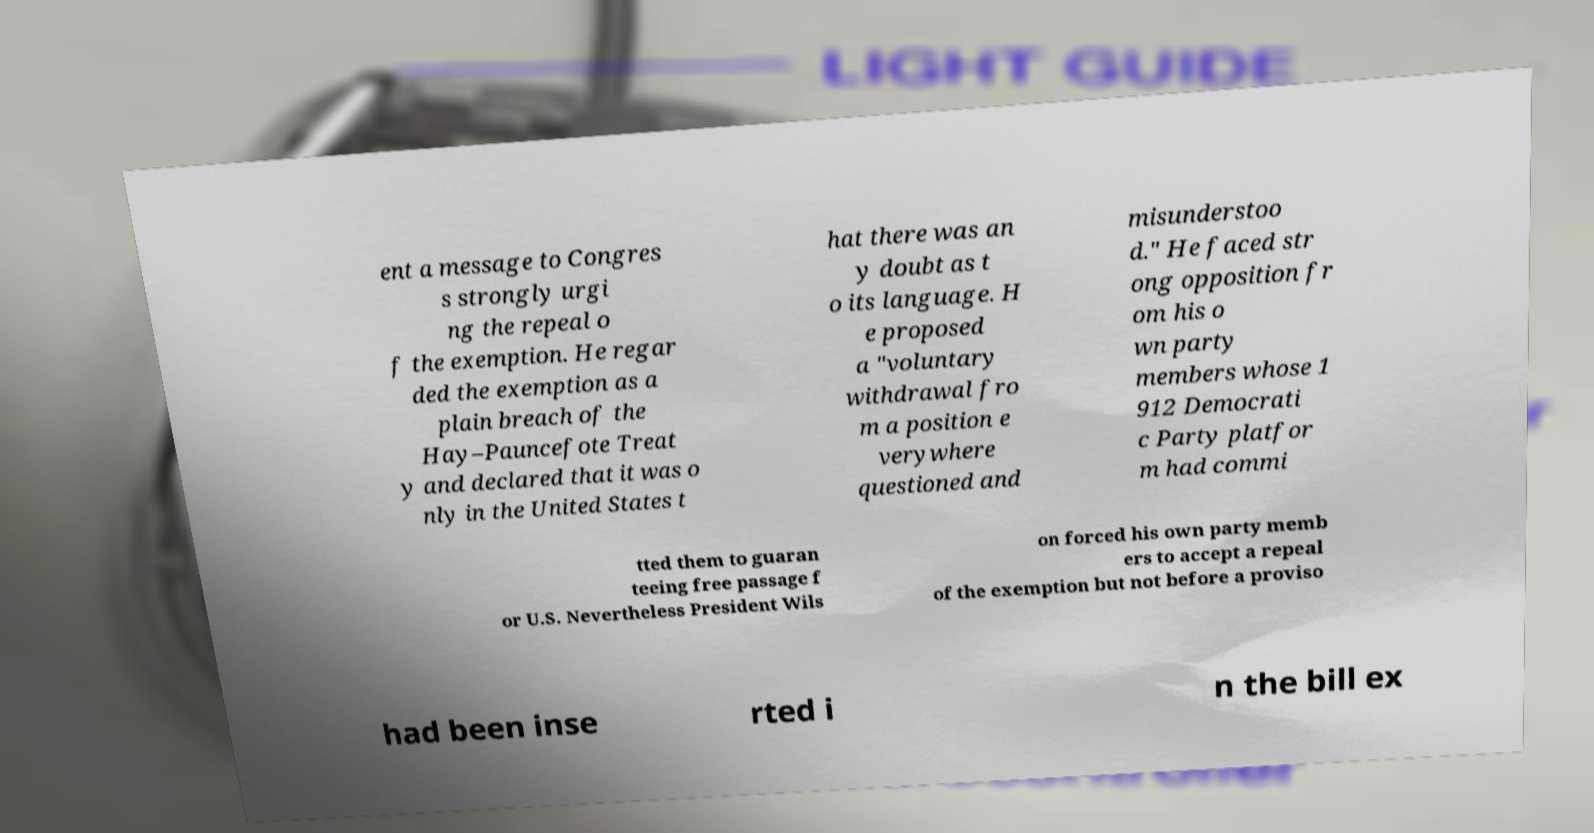Can you read and provide the text displayed in the image?This photo seems to have some interesting text. Can you extract and type it out for me? ent a message to Congres s strongly urgi ng the repeal o f the exemption. He regar ded the exemption as a plain breach of the Hay–Pauncefote Treat y and declared that it was o nly in the United States t hat there was an y doubt as t o its language. H e proposed a "voluntary withdrawal fro m a position e verywhere questioned and misunderstoo d." He faced str ong opposition fr om his o wn party members whose 1 912 Democrati c Party platfor m had commi tted them to guaran teeing free passage f or U.S. Nevertheless President Wils on forced his own party memb ers to accept a repeal of the exemption but not before a proviso had been inse rted i n the bill ex 